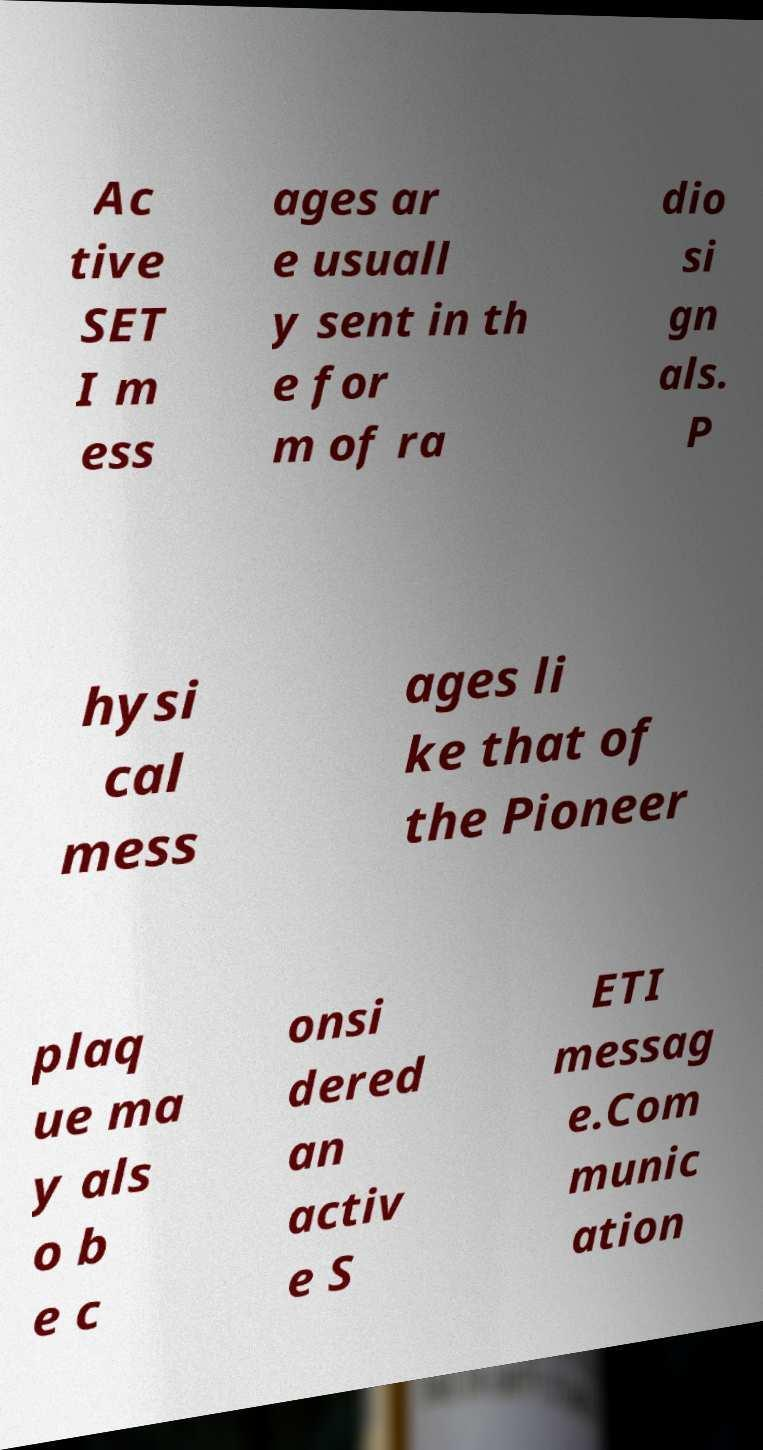I need the written content from this picture converted into text. Can you do that? Ac tive SET I m ess ages ar e usuall y sent in th e for m of ra dio si gn als. P hysi cal mess ages li ke that of the Pioneer plaq ue ma y als o b e c onsi dered an activ e S ETI messag e.Com munic ation 